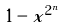Convert formula to latex. <formula><loc_0><loc_0><loc_500><loc_500>1 - x ^ { 2 ^ { n } }</formula> 